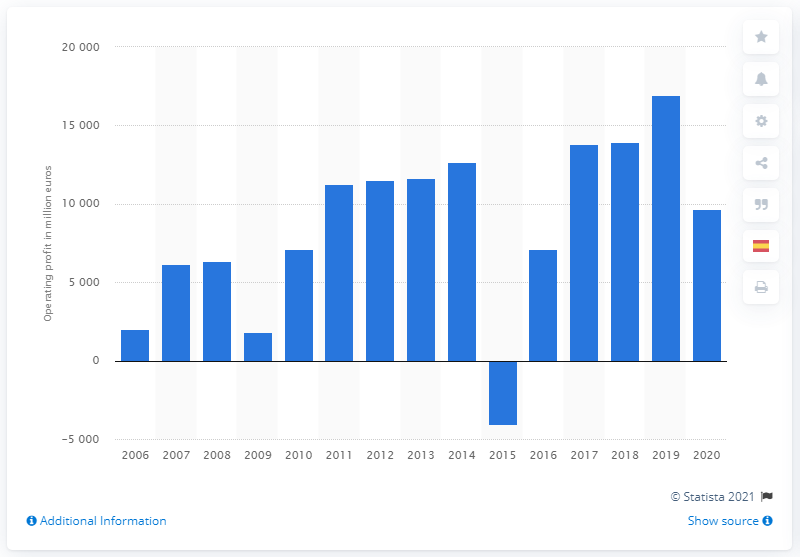Point out several critical features in this image. Volkswagen's operating profit in 2020 was 9,675. 